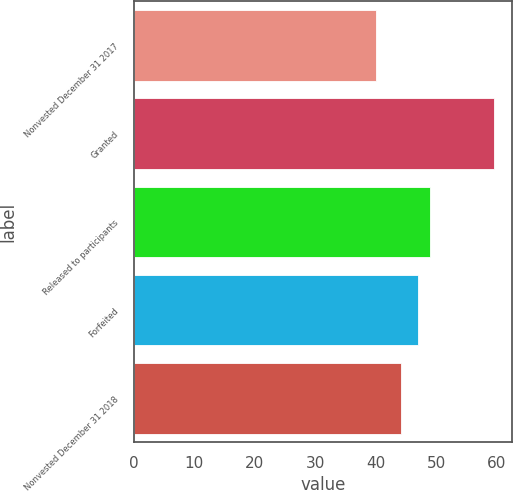Convert chart to OTSL. <chart><loc_0><loc_0><loc_500><loc_500><bar_chart><fcel>Nonvested December 31 2017<fcel>Granted<fcel>Released to participants<fcel>Forfeited<fcel>Nonvested December 31 2018<nl><fcel>40.08<fcel>59.57<fcel>48.92<fcel>46.97<fcel>44.08<nl></chart> 